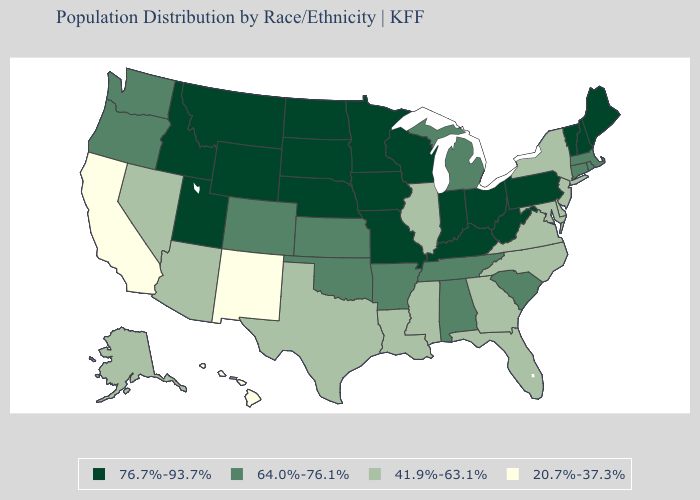What is the value of Idaho?
Concise answer only. 76.7%-93.7%. What is the lowest value in the Northeast?
Keep it brief. 41.9%-63.1%. Which states have the lowest value in the MidWest?
Short answer required. Illinois. What is the value of Missouri?
Write a very short answer. 76.7%-93.7%. Among the states that border Oregon , which have the lowest value?
Be succinct. California. Does the first symbol in the legend represent the smallest category?
Give a very brief answer. No. What is the lowest value in the USA?
Keep it brief. 20.7%-37.3%. Is the legend a continuous bar?
Write a very short answer. No. What is the value of Pennsylvania?
Concise answer only. 76.7%-93.7%. What is the value of Indiana?
Answer briefly. 76.7%-93.7%. Among the states that border North Dakota , which have the lowest value?
Quick response, please. Minnesota, Montana, South Dakota. Does Pennsylvania have a higher value than South Dakota?
Quick response, please. No. What is the value of New Jersey?
Be succinct. 41.9%-63.1%. What is the lowest value in the West?
Short answer required. 20.7%-37.3%. Which states have the lowest value in the Northeast?
Keep it brief. New Jersey, New York. 